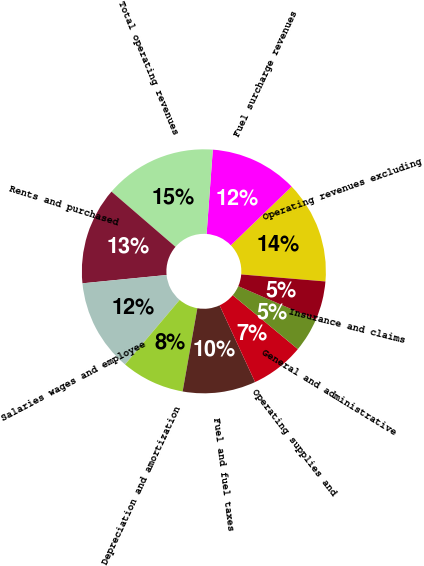Convert chart. <chart><loc_0><loc_0><loc_500><loc_500><pie_chart><fcel>Operating revenues excluding<fcel>Fuel surcharge revenues<fcel>Total operating revenues<fcel>Rents and purchased<fcel>Salaries wages and employee<fcel>Depreciation and amortization<fcel>Fuel and fuel taxes<fcel>Operating supplies and<fcel>General and administrative<fcel>Insurance and claims<nl><fcel>13.55%<fcel>11.61%<fcel>14.84%<fcel>12.9%<fcel>12.26%<fcel>8.39%<fcel>9.68%<fcel>7.1%<fcel>4.52%<fcel>5.16%<nl></chart> 